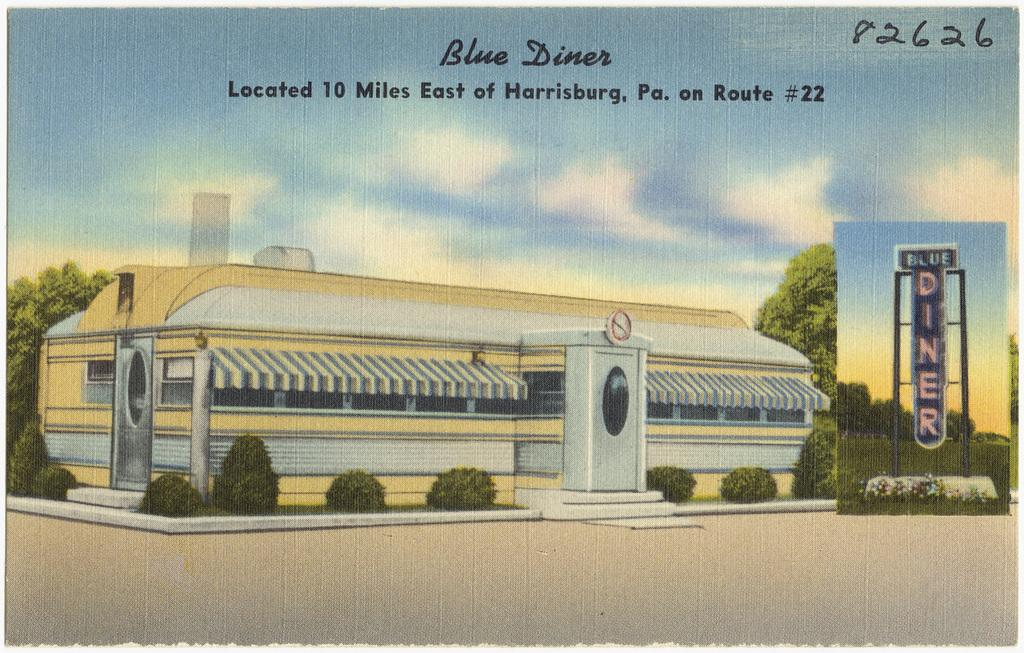<image>
Describe the image concisely. The "Blue Diner" is drawn with a blue sky above. 